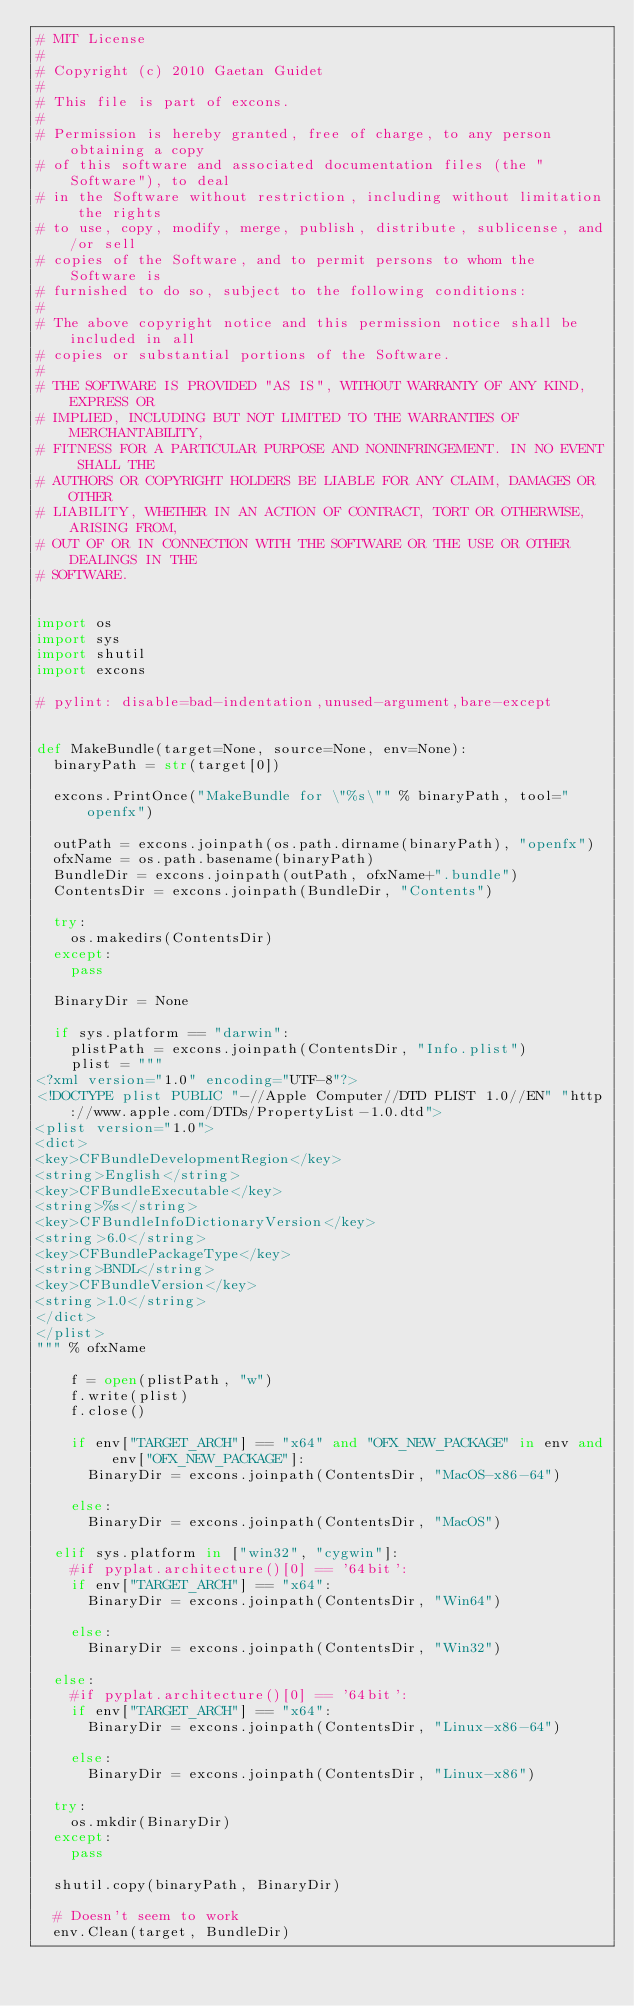Convert code to text. <code><loc_0><loc_0><loc_500><loc_500><_Python_># MIT License
#
# Copyright (c) 2010 Gaetan Guidet
#
# This file is part of excons.
#
# Permission is hereby granted, free of charge, to any person obtaining a copy
# of this software and associated documentation files (the "Software"), to deal
# in the Software without restriction, including without limitation the rights
# to use, copy, modify, merge, publish, distribute, sublicense, and/or sell
# copies of the Software, and to permit persons to whom the Software is
# furnished to do so, subject to the following conditions:
#
# The above copyright notice and this permission notice shall be included in all
# copies or substantial portions of the Software.
#
# THE SOFTWARE IS PROVIDED "AS IS", WITHOUT WARRANTY OF ANY KIND, EXPRESS OR
# IMPLIED, INCLUDING BUT NOT LIMITED TO THE WARRANTIES OF MERCHANTABILITY,
# FITNESS FOR A PARTICULAR PURPOSE AND NONINFRINGEMENT. IN NO EVENT SHALL THE
# AUTHORS OR COPYRIGHT HOLDERS BE LIABLE FOR ANY CLAIM, DAMAGES OR OTHER
# LIABILITY, WHETHER IN AN ACTION OF CONTRACT, TORT OR OTHERWISE, ARISING FROM,
# OUT OF OR IN CONNECTION WITH THE SOFTWARE OR THE USE OR OTHER DEALINGS IN THE
# SOFTWARE.


import os
import sys
import shutil
import excons

# pylint: disable=bad-indentation,unused-argument,bare-except


def MakeBundle(target=None, source=None, env=None):
  binaryPath = str(target[0])
  
  excons.PrintOnce("MakeBundle for \"%s\"" % binaryPath, tool="openfx")
  
  outPath = excons.joinpath(os.path.dirname(binaryPath), "openfx")
  ofxName = os.path.basename(binaryPath)
  BundleDir = excons.joinpath(outPath, ofxName+".bundle")
  ContentsDir = excons.joinpath(BundleDir, "Contents")
  
  try:
    os.makedirs(ContentsDir)
  except:
    pass
  
  BinaryDir = None
  
  if sys.platform == "darwin":
    plistPath = excons.joinpath(ContentsDir, "Info.plist")
    plist = """
<?xml version="1.0" encoding="UTF-8"?>
<!DOCTYPE plist PUBLIC "-//Apple Computer//DTD PLIST 1.0//EN" "http://www.apple.com/DTDs/PropertyList-1.0.dtd">
<plist version="1.0">
<dict>
<key>CFBundleDevelopmentRegion</key>
<string>English</string>
<key>CFBundleExecutable</key>
<string>%s</string>
<key>CFBundleInfoDictionaryVersion</key>
<string>6.0</string>
<key>CFBundlePackageType</key>
<string>BNDL</string>
<key>CFBundleVersion</key>
<string>1.0</string>
</dict>
</plist>
""" % ofxName
    
    f = open(plistPath, "w")
    f.write(plist)
    f.close()
    
    if env["TARGET_ARCH"] == "x64" and "OFX_NEW_PACKAGE" in env and env["OFX_NEW_PACKAGE"]:
      BinaryDir = excons.joinpath(ContentsDir, "MacOS-x86-64")
      
    else:
      BinaryDir = excons.joinpath(ContentsDir, "MacOS")
  
  elif sys.platform in ["win32", "cygwin"]:
    #if pyplat.architecture()[0] == '64bit':
    if env["TARGET_ARCH"] == "x64":
      BinaryDir = excons.joinpath(ContentsDir, "Win64")
      
    else:
      BinaryDir = excons.joinpath(ContentsDir, "Win32")
  
  else:
    #if pyplat.architecture()[0] == '64bit':
    if env["TARGET_ARCH"] == "x64":
      BinaryDir = excons.joinpath(ContentsDir, "Linux-x86-64")
      
    else:
      BinaryDir = excons.joinpath(ContentsDir, "Linux-x86")
  
  try:
    os.mkdir(BinaryDir)
  except:
    pass
  
  shutil.copy(binaryPath, BinaryDir)
  
  # Doesn't seem to work
  env.Clean(target, BundleDir)
</code> 